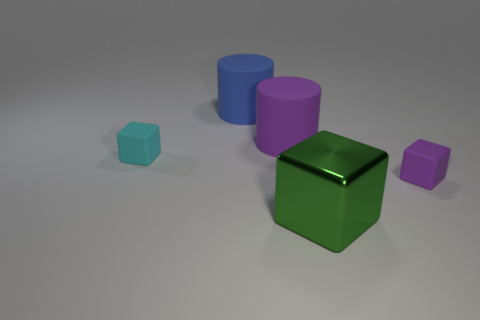There is a purple object to the right of the big purple rubber object; what is it made of?
Offer a very short reply. Rubber. There is a green object that is the same shape as the tiny cyan matte thing; what is its size?
Provide a short and direct response. Large. Are there fewer tiny blocks behind the blue cylinder than small cyan cubes?
Make the answer very short. Yes. Are there any big purple objects?
Provide a succinct answer. Yes. There is another big object that is the same shape as the large blue object; what color is it?
Make the answer very short. Purple. Do the purple matte block and the purple cylinder have the same size?
Provide a short and direct response. No. What is the shape of the large blue thing that is the same material as the small purple cube?
Offer a very short reply. Cylinder. How many other things are the same shape as the metallic object?
Offer a very short reply. 2. What shape is the purple thing that is behind the small thing that is in front of the rubber block that is behind the small purple rubber cube?
Offer a very short reply. Cylinder. How many cylinders are tiny blue metallic objects or big matte objects?
Offer a very short reply. 2. 